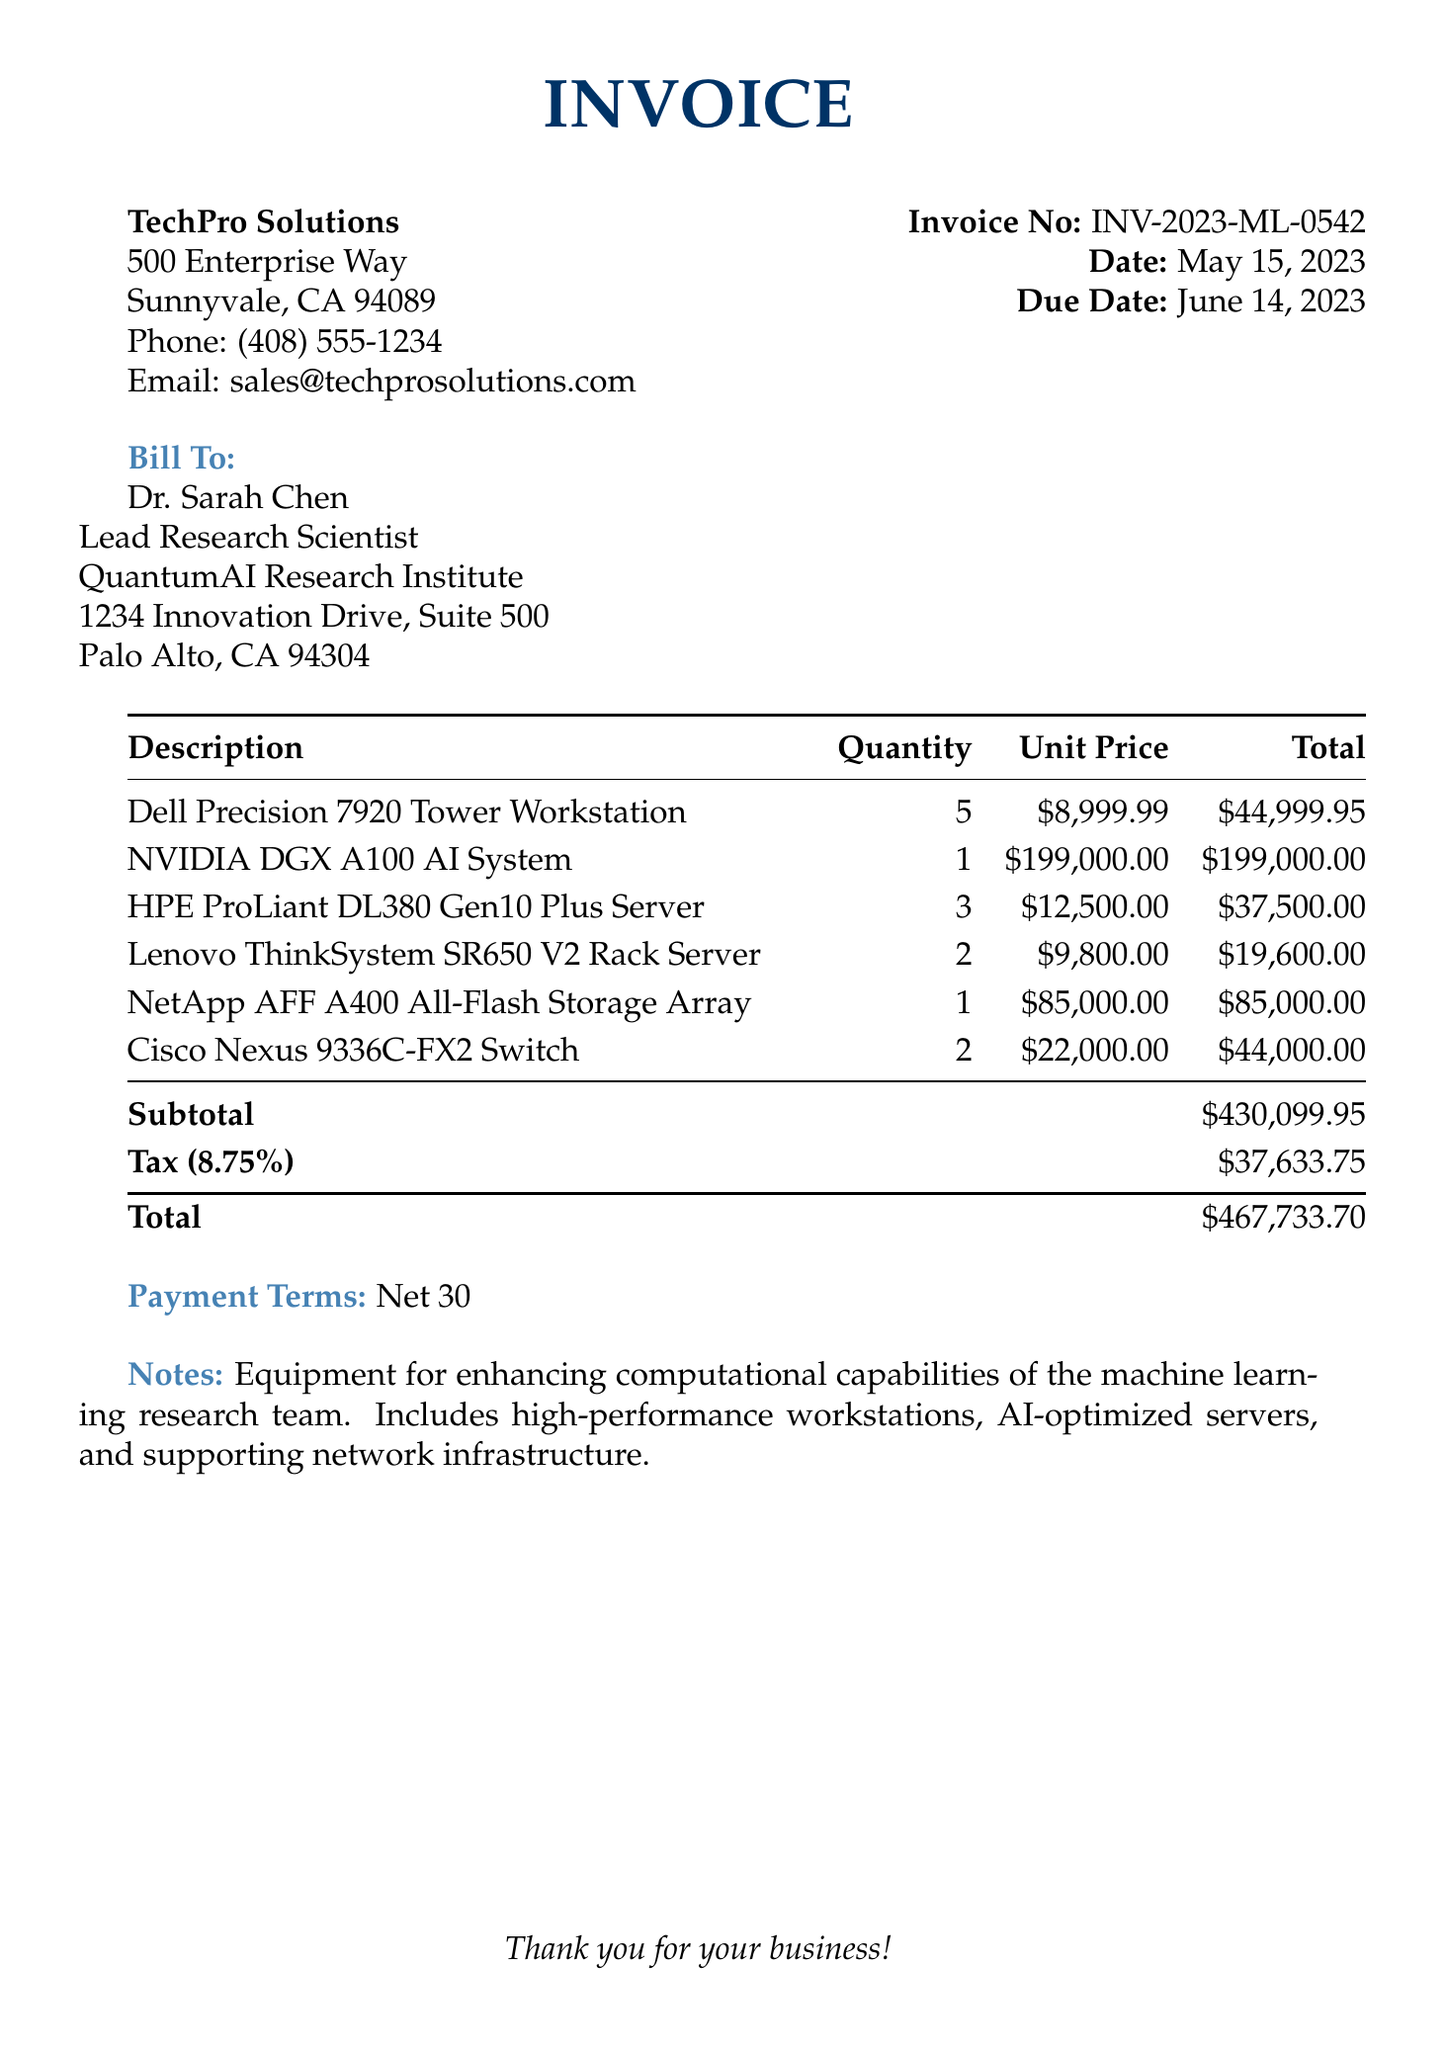What is the invoice number? The invoice number is listed at the top right corner of the document.
Answer: INV-2023-ML-0542 What is the due date? The due date is mentioned below the invoice details.
Answer: June 14, 2023 Who is the billing address for? The name listed in the billing address section indicates who the bill is for.
Answer: Dr. Sarah Chen What is the subtotal amount? The subtotal is detailed in the itemized listing near the bottom of the invoice.
Answer: $430,099.95 How many Dell Precision 7920 Tower Workstations were purchased? The quantity can be found in the itemized list of equipment.
Answer: 5 What is the tax rate applied to the invoice? The tax rate is stated right before the tax amount.
Answer: 8.75% What is the total amount due? The total is clearly highlighted at the bottom of the invoice.
Answer: $467,733.70 What is the payment term stated in the invoice? The payment terms are mentioned explicitly in the invoice.
Answer: Net 30 What is the total quantity of Cisco Nexus 9336C-FX2 Switches purchased? The quantity is indicated in the itemized equipment section.
Answer: 2 